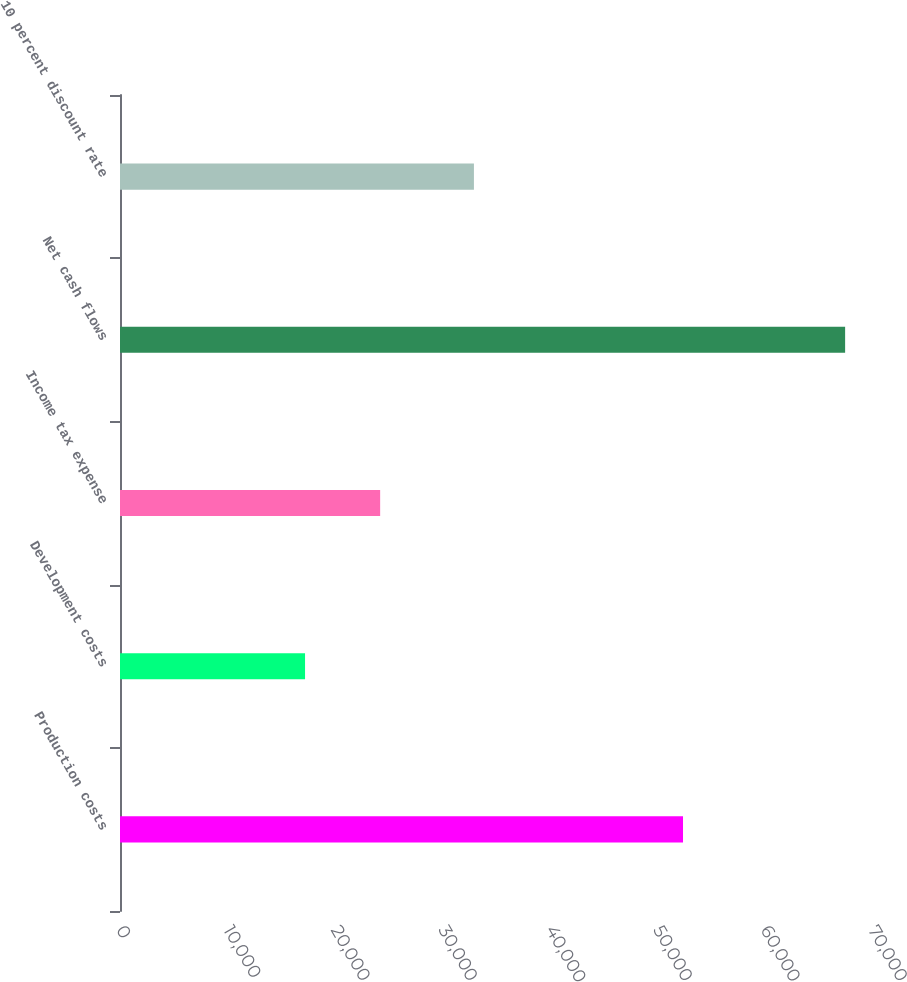<chart> <loc_0><loc_0><loc_500><loc_500><bar_chart><fcel>Production costs<fcel>Development costs<fcel>Income tax expense<fcel>Net cash flows<fcel>10 percent discount rate<nl><fcel>52408<fcel>17225<fcel>24216<fcel>67498<fcel>32945<nl></chart> 